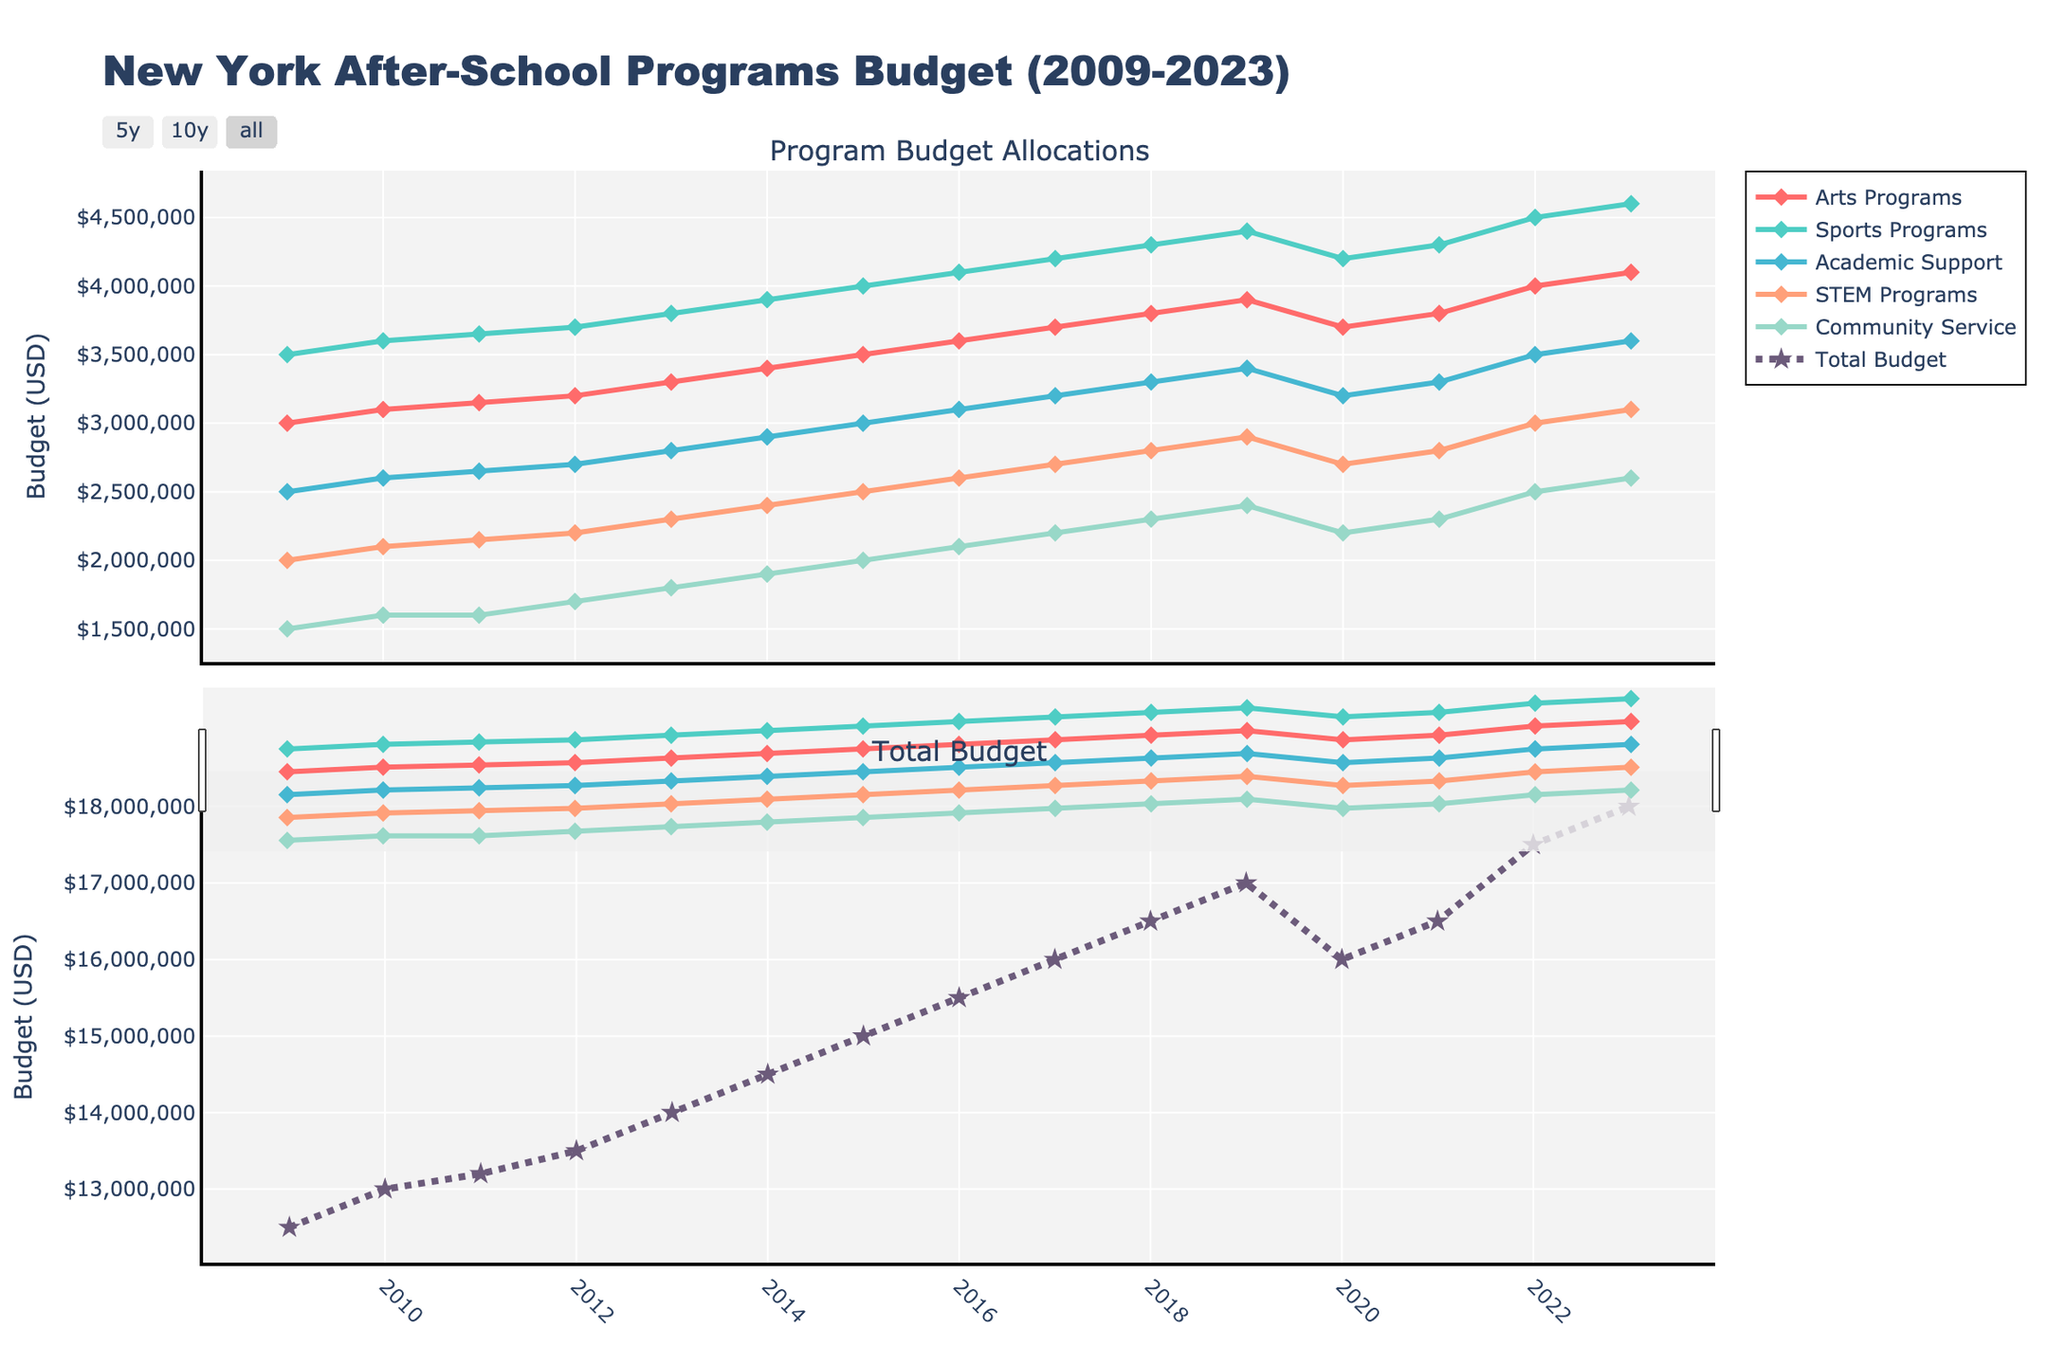What was the allocated budget for STEM Programs in 2023? In the 2023 data point under the "STEM Programs" line in the first subplot, the y-axis value shows 3100000 USD.
Answer: 3100000 USD By how much did the total budget increase from 2009 to 2023? Looking at the "Total Budget" line in the second subplot, the value in 2009 was 12500000 USD and in 2023 it was 18000000 USD. Calculating the difference: 18000000 - 12500000.
Answer: 5500000 USD Which program received the highest budget allocation in 2018? Observing the 2018 data points in the first subplot, the "Sports Programs" line is the highest at 4300000 USD.
Answer: Sports Programs During which year(s) did the total budget decrease compared to the previous year? Comparing the "Total Budget" line plot in the second subplot over the years, there is a visible decrease between 2019 (17000000 USD) and 2020 (16000000 USD).
Answer: 2020 In which year did Community Service Programs first reach an allocation of 2000000 USD? The "Community Service Programs" line in the first subplot first crosses the 2000000 USD mark in 2015.
Answer: 2015 How many years did the total budget stay the same? Checking the "Total Budget" line in the second subplot for any flat periods, we observe the total budget remained the same between 2021 and 2022, indicating a flat budget of 16500000 USD for one year.
Answer: 1 year (2021-2022) Comparing 2009 and 2023, which program had the largest percentage increase in budget allocation? To find the percentage increase, the formula (New Value - Old Value)/Old Value * 100 is used:
- Arts Programs: (4100000 - 3000000)/3000000 * 100 = 36.67%
- Sports Programs: (4600000 - 3500000)/3500000 * 100 = 31.43%
- Academic Support: (3600000 - 2500000)/2500000 * 100 = 44%
- STEM Programs: (3100000 - 2000000)/2000000 * 100 = 55%
- Community Service: (2600000 - 1500000)/1500000 * 100 = 73.33%
 
Thus, Community Service had the largest percentage increase.
Answer: Community Service, 73.33% Between which consecutive years did the STEM Programs see the largest single-year increase in budget allocation? Analyzing the differences year by year for STEM Programs (e.g., 2010: 2100000, 2011: 2150000, etc.), the largest increase is between 2021 (2800000 USD) and 2022 (3000000 USD), with a 200000 USD increase.
Answer: 2021-2022 (200000 USD) What are the colors representing the Arts Programs and STEM Programs in the plot? The visual elements show that Arts Programs are marked in red and STEM Programs are marked in salmon color.
Answer: Arts: red, STEM: salmon How did budget allocation trends for Academic Support and Community Service compare between 2009 and 2013? By tracing the lines for Academic Support and Community Service in the first subplot from 2009 to 2013:
- Academic Support increased from 2500000 to 2800000 USD.
- Community Service increased from 1500000 to 1800000 USD.
Both show an upward trend but Academic Support had a relatively larger increase.
Answer: Both increased, but Academic Support had a larger increase 